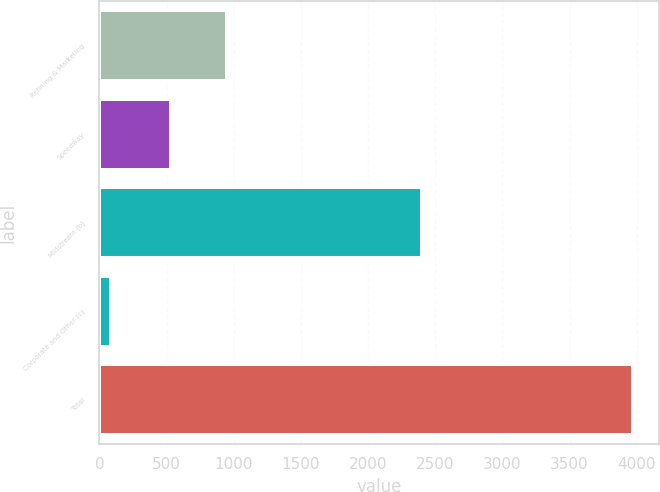Convert chart to OTSL. <chart><loc_0><loc_0><loc_500><loc_500><bar_chart><fcel>Refining & Marketing<fcel>Speedway<fcel>Midstream (b)<fcel>Corporate and Other (c)<fcel>Total<nl><fcel>950<fcel>530<fcel>2405<fcel>85<fcel>3970<nl></chart> 